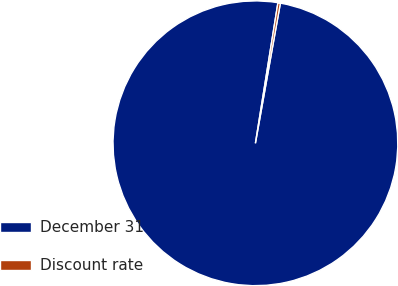Convert chart. <chart><loc_0><loc_0><loc_500><loc_500><pie_chart><fcel>December 31<fcel>Discount rate<nl><fcel>99.72%<fcel>0.28%<nl></chart> 